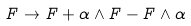<formula> <loc_0><loc_0><loc_500><loc_500>F \rightarrow F + \alpha \wedge F - F \wedge \alpha</formula> 